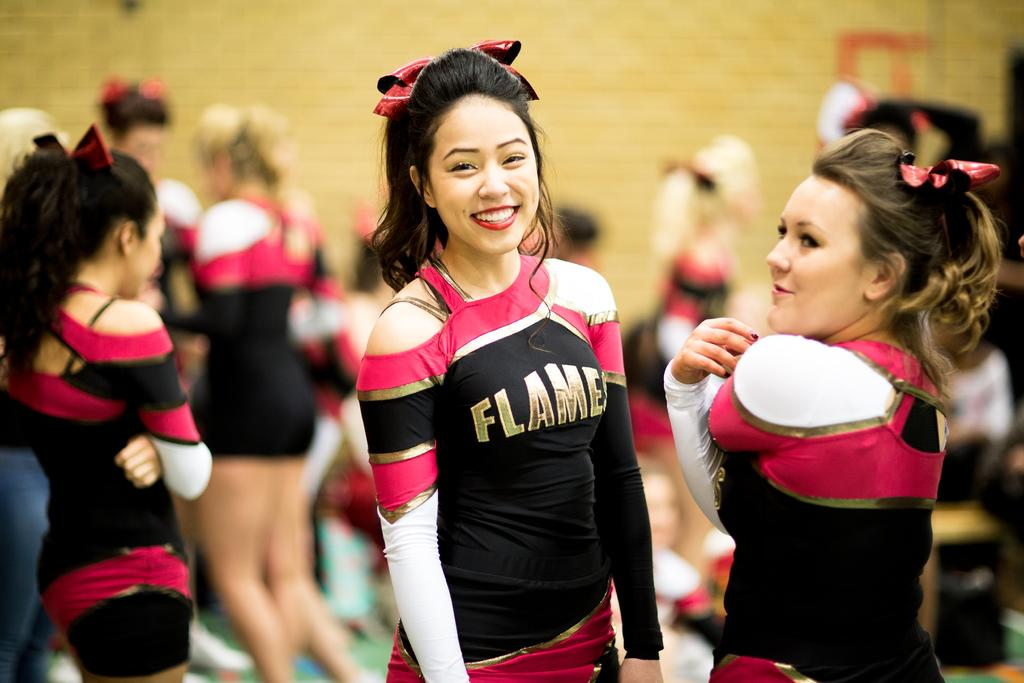<image>
Give a short and clear explanation of the subsequent image. A girl has a uniform on with the word flames on the front. 